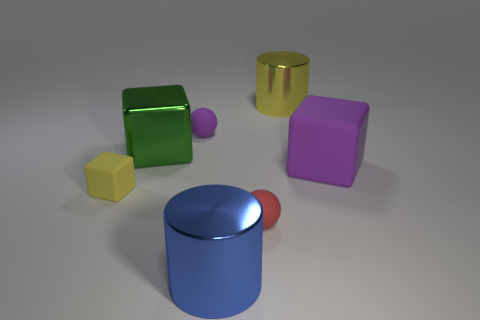Add 1 tiny cyan blocks. How many objects exist? 8 Subtract all gray matte balls. Subtract all large purple blocks. How many objects are left? 6 Add 4 tiny purple rubber things. How many tiny purple rubber things are left? 5 Add 4 rubber cubes. How many rubber cubes exist? 6 Subtract 0 red blocks. How many objects are left? 7 Subtract all cubes. How many objects are left? 4 